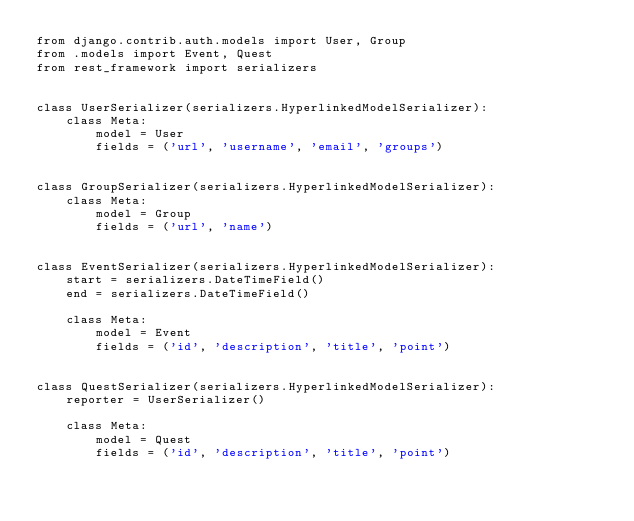<code> <loc_0><loc_0><loc_500><loc_500><_Python_>from django.contrib.auth.models import User, Group
from .models import Event, Quest
from rest_framework import serializers


class UserSerializer(serializers.HyperlinkedModelSerializer):
    class Meta:
        model = User
        fields = ('url', 'username', 'email', 'groups')


class GroupSerializer(serializers.HyperlinkedModelSerializer):
    class Meta:
        model = Group
        fields = ('url', 'name')


class EventSerializer(serializers.HyperlinkedModelSerializer):
    start = serializers.DateTimeField()
    end = serializers.DateTimeField()

    class Meta:
        model = Event
        fields = ('id', 'description', 'title', 'point')


class QuestSerializer(serializers.HyperlinkedModelSerializer):
    reporter = UserSerializer()

    class Meta:
        model = Quest
        fields = ('id', 'description', 'title', 'point')
</code> 